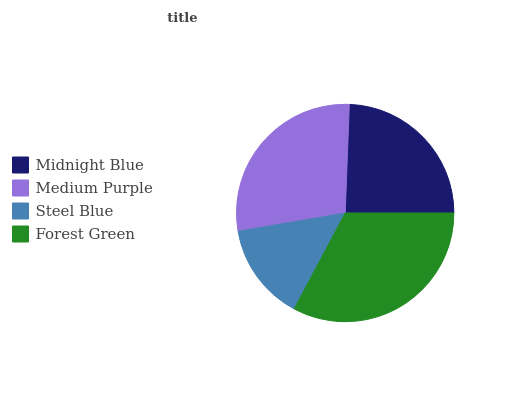Is Steel Blue the minimum?
Answer yes or no. Yes. Is Forest Green the maximum?
Answer yes or no. Yes. Is Medium Purple the minimum?
Answer yes or no. No. Is Medium Purple the maximum?
Answer yes or no. No. Is Medium Purple greater than Midnight Blue?
Answer yes or no. Yes. Is Midnight Blue less than Medium Purple?
Answer yes or no. Yes. Is Midnight Blue greater than Medium Purple?
Answer yes or no. No. Is Medium Purple less than Midnight Blue?
Answer yes or no. No. Is Medium Purple the high median?
Answer yes or no. Yes. Is Midnight Blue the low median?
Answer yes or no. Yes. Is Steel Blue the high median?
Answer yes or no. No. Is Medium Purple the low median?
Answer yes or no. No. 